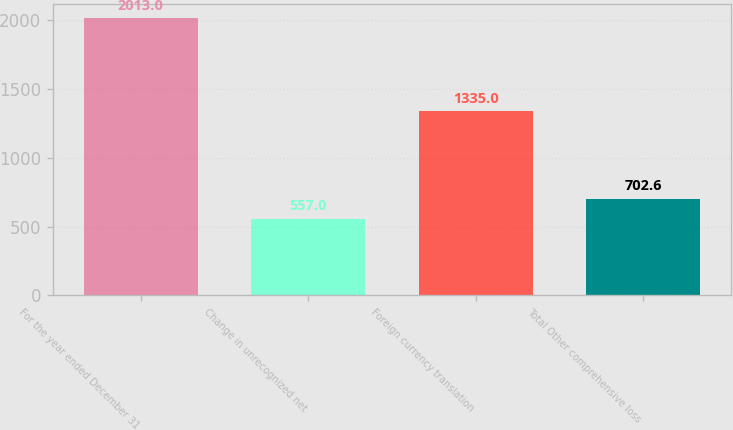Convert chart. <chart><loc_0><loc_0><loc_500><loc_500><bar_chart><fcel>For the year ended December 31<fcel>Change in unrecognized net<fcel>Foreign currency translation<fcel>Total Other comprehensive loss<nl><fcel>2013<fcel>557<fcel>1335<fcel>702.6<nl></chart> 